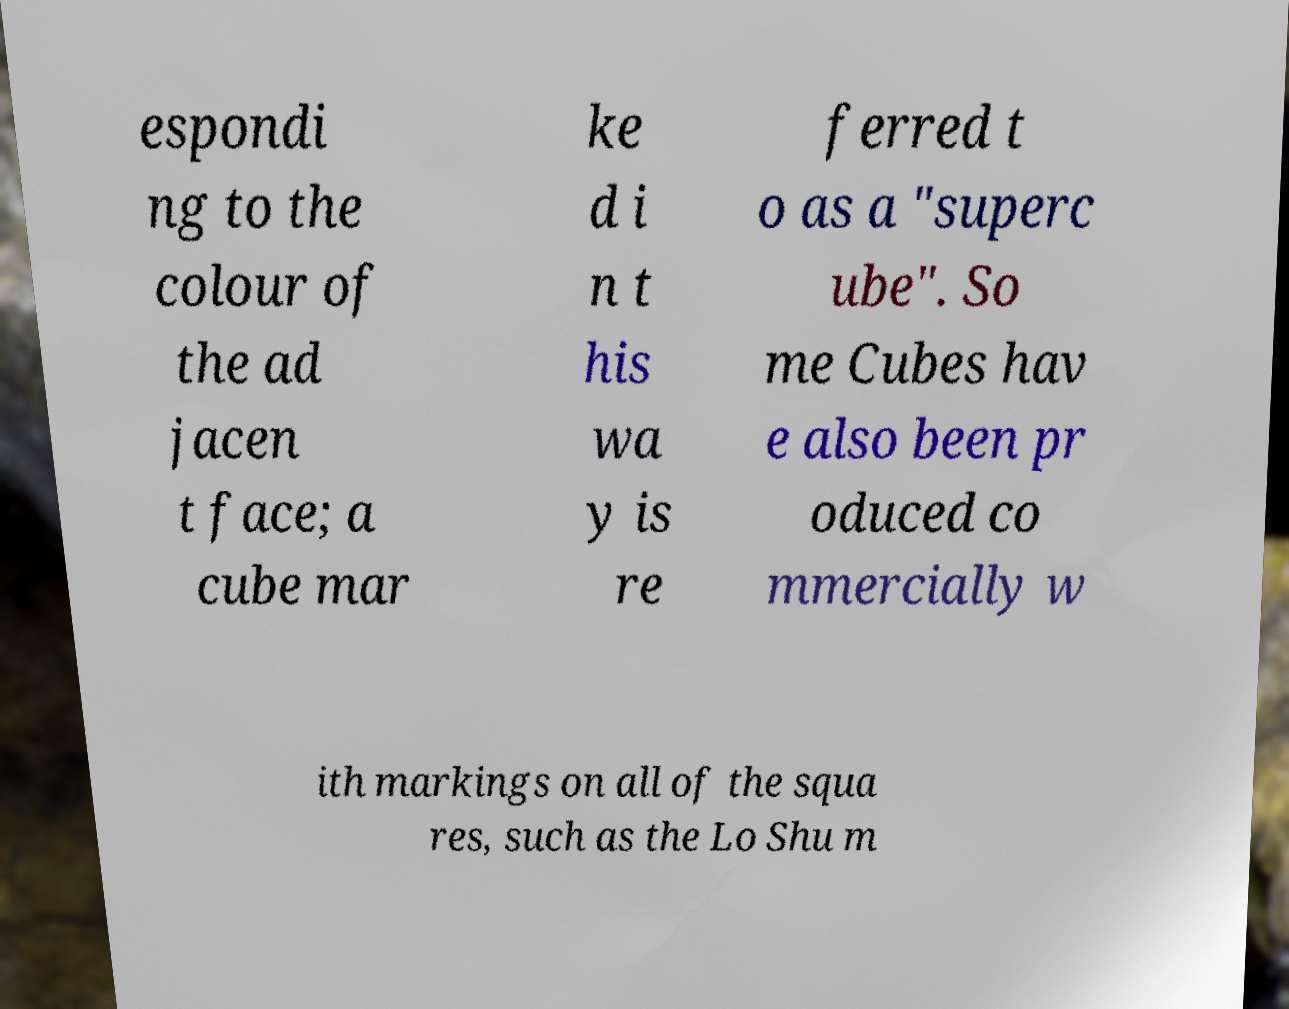Please identify and transcribe the text found in this image. espondi ng to the colour of the ad jacen t face; a cube mar ke d i n t his wa y is re ferred t o as a "superc ube". So me Cubes hav e also been pr oduced co mmercially w ith markings on all of the squa res, such as the Lo Shu m 